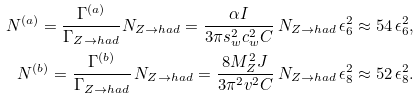<formula> <loc_0><loc_0><loc_500><loc_500>N ^ { ( a ) } = \frac { \Gamma ^ { ( a ) } } { \Gamma _ { Z \to h a d } } N _ { Z \to h a d } = \frac { \alpha I } { 3 \pi s _ { w } ^ { 2 } c _ { w } ^ { 2 } C } \, N _ { Z \to h a d } \, \epsilon _ { 6 } ^ { 2 } \approx 5 4 \, \epsilon _ { 6 } ^ { 2 } , \\ N ^ { ( b ) } = \frac { \Gamma ^ { ( b ) } } { \Gamma _ { Z \to h a d } } \, N _ { Z \to h a d } = \frac { 8 M _ { Z } ^ { 2 } J } { 3 \pi ^ { 2 } v ^ { 2 } C } \, N _ { Z \to h a d } \, \epsilon _ { 8 } ^ { 2 } \approx 5 2 \, \epsilon _ { 8 } ^ { 2 } .</formula> 